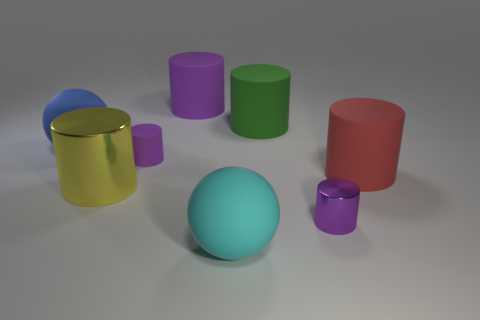How do the objects in the image relate to each other in terms of size? In terms of size, the objects are varied. The green and red cylinders are the largest in terms of height, followed closely by the metallic gold and blue cylinders. The purple cylinder is the smallest, and the lime green and pink cylinders are a bit taller but also slim. The sphere is unique in shape and is closest in size to the smaller cylinders. 